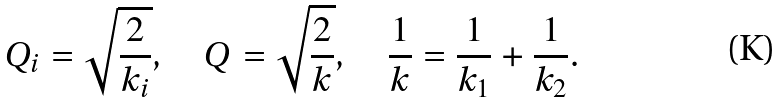<formula> <loc_0><loc_0><loc_500><loc_500>Q _ { i } = \sqrt { \frac { 2 } { k _ { i } } } , \quad Q = \sqrt { \frac { 2 } { k } } , \quad \frac { 1 } { k } = \frac { 1 } { k _ { 1 } } + \frac { 1 } { k _ { 2 } } .</formula> 